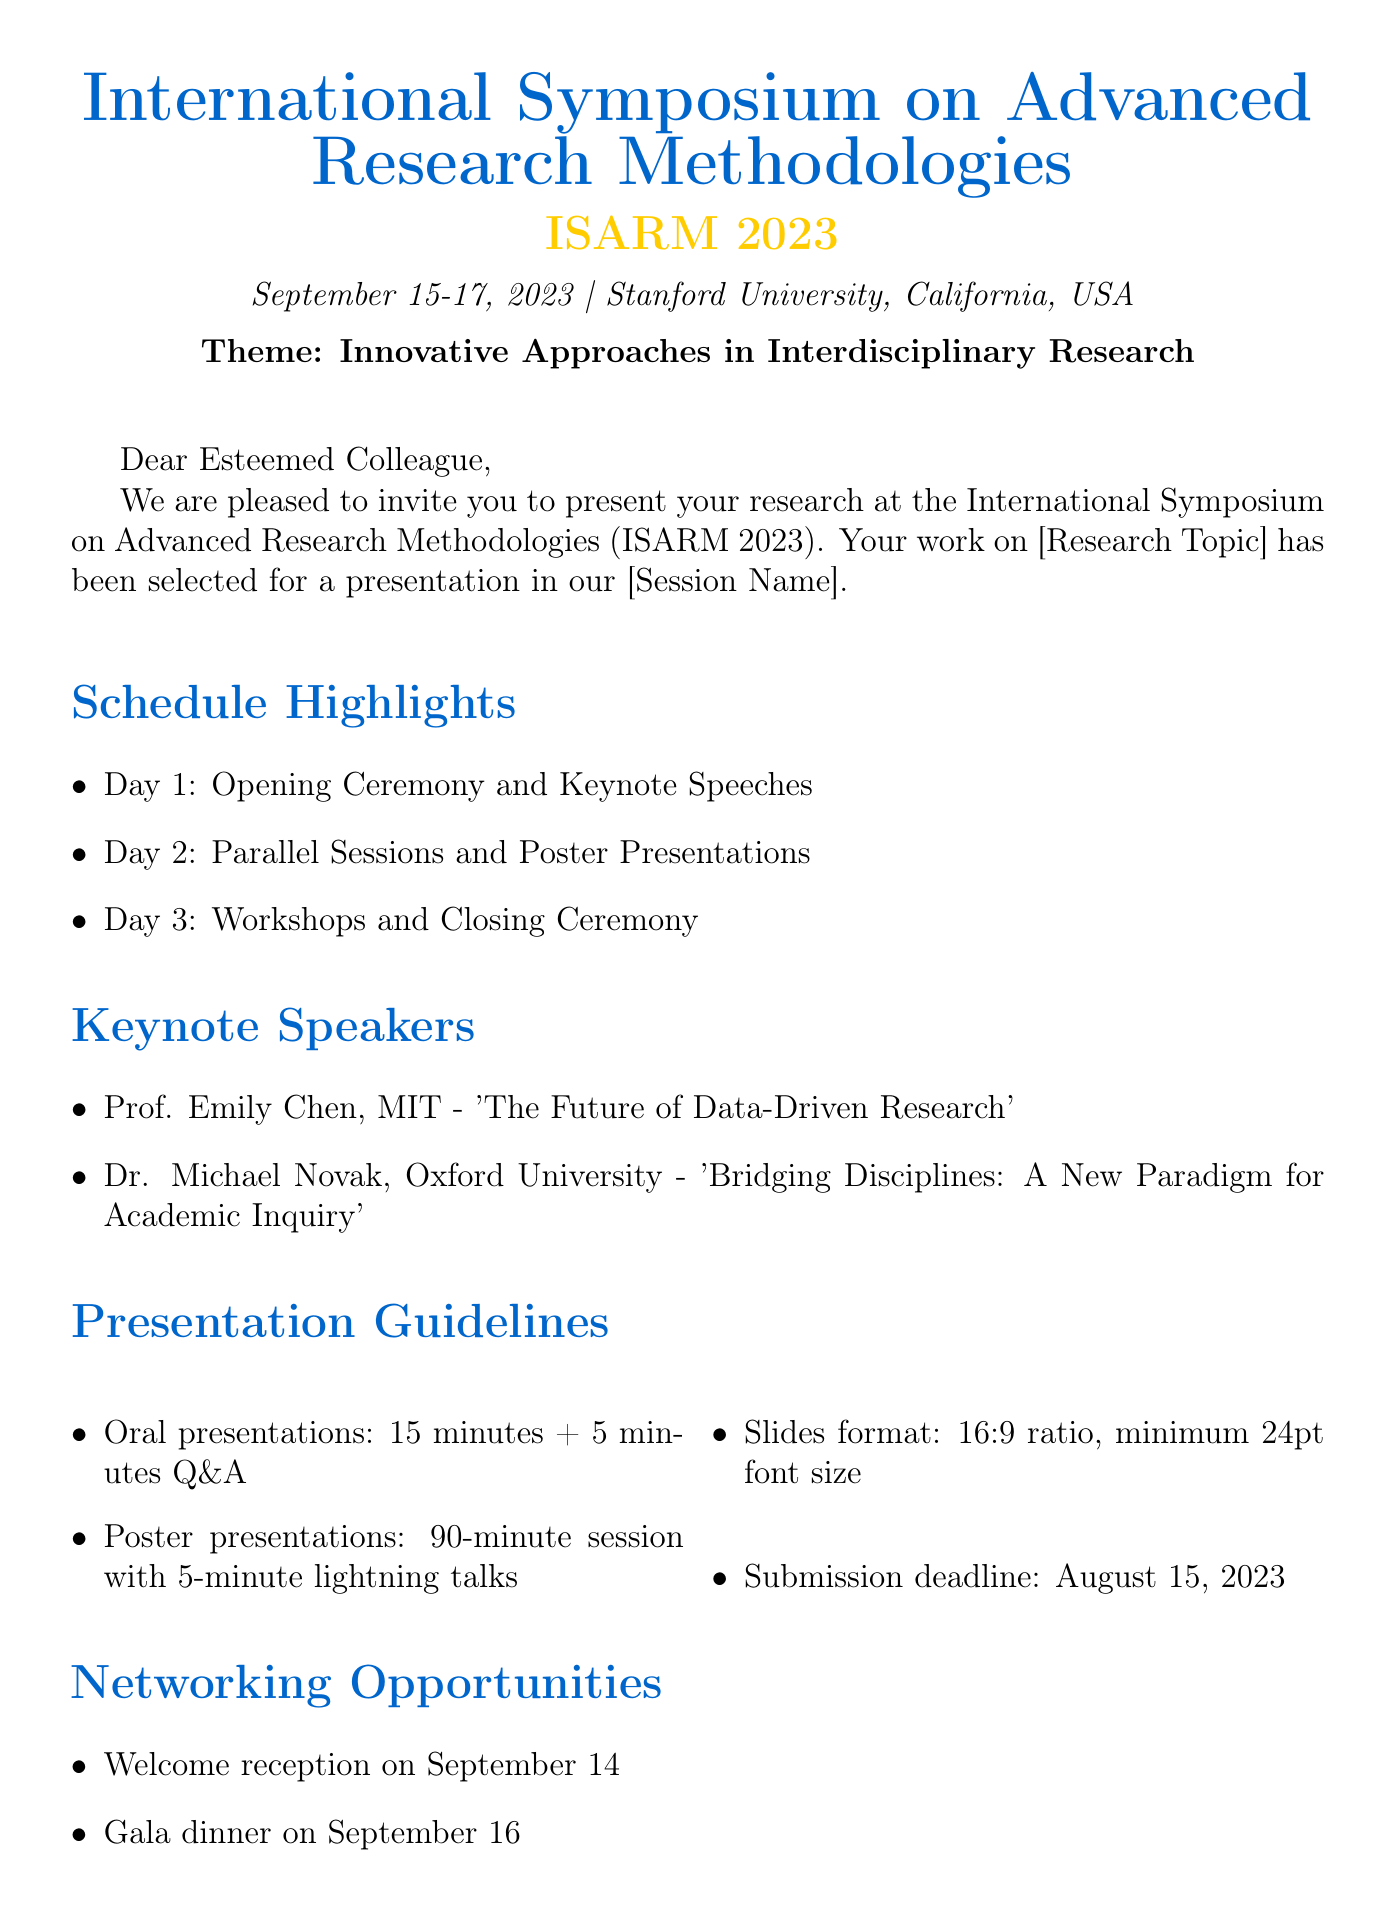What is the name of the conference? The name of the conference is explicitly mentioned in the invitation letter at the top of the document.
Answer: International Symposium on Advanced Research Methodologies What are the dates of the conference? The dates are presented in the introductory paragraph of the document, specifying when the event will occur.
Answer: September 15-17, 2023 Where is the conference taking place? The venue is located within the same introductory section of the document.
Answer: Stanford University, California, USA Who are the keynote speakers? The document lists the keynote speakers under a specific section, providing their names and affiliations.
Answer: Prof. Emily Chen, Dr. Michael Novak What is the submission deadline for presentations? The deadline is specified in the Presentation Guidelines section of the invitation letter.
Answer: August 15, 2023 How long is each oral presentation? The duration for oral presentations is detailed within the Presentation Guidelines section.
Answer: 15 minutes What is the early bird registration deadline? The early bird registration deadline is stated within the Registration section of the document.
Answer: July 31, 2023 What type of networking opportunity is available on September 16? The document indicates networking opportunities within a specific section.
Answer: Gala dinner What format should presentation slides be in? The guidelines state the required format for slides in the Presentation Guidelines section.
Answer: 16:9 ratio, minimum 24pt font size 